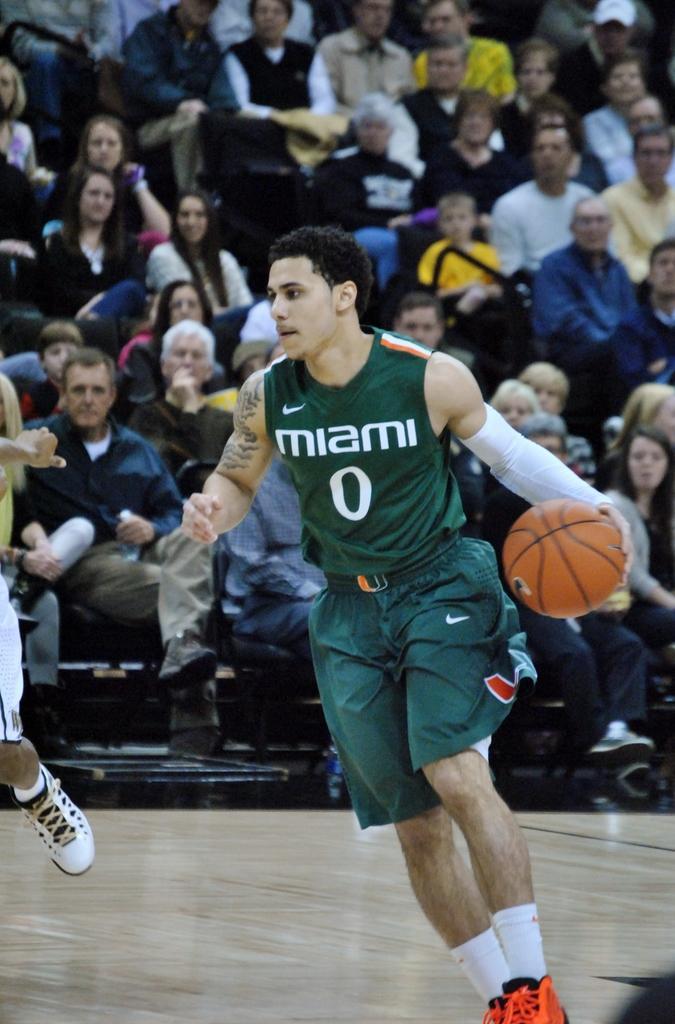Could you give a brief overview of what you see in this image? In the middle of the image a person is running and holding a basketball. Behind him few people are sitting and watching. 